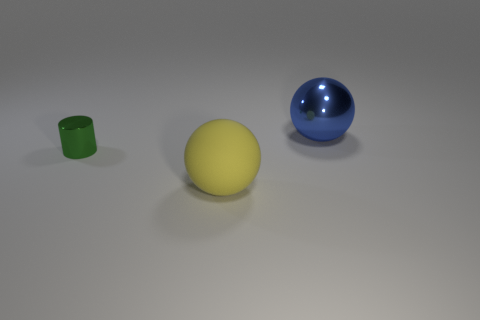Add 3 metal spheres. How many objects exist? 6 Subtract all spheres. How many objects are left? 1 Subtract 0 red cylinders. How many objects are left? 3 Subtract all tiny yellow matte balls. Subtract all tiny green things. How many objects are left? 2 Add 1 matte things. How many matte things are left? 2 Add 2 blue metallic objects. How many blue metallic objects exist? 3 